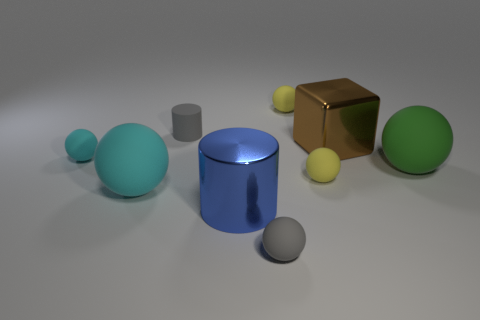Subtract all yellow balls. How many balls are left? 4 Subtract all yellow rubber spheres. How many spheres are left? 4 Subtract all red cylinders. Subtract all blue balls. How many cylinders are left? 2 Add 1 green matte objects. How many objects exist? 10 Subtract all balls. How many objects are left? 3 Add 6 large matte things. How many large matte things are left? 8 Add 6 purple cylinders. How many purple cylinders exist? 6 Subtract 1 gray spheres. How many objects are left? 8 Subtract all big green spheres. Subtract all large yellow cubes. How many objects are left? 8 